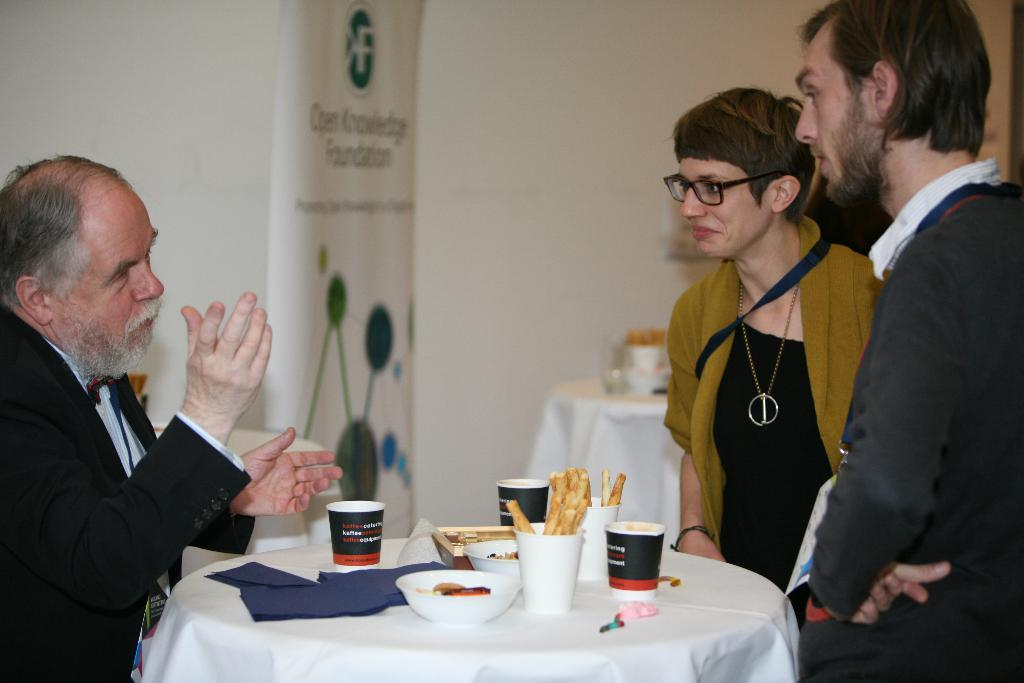How many people are present in the image? There are three people in the image. What is the position of one of the men in the image? One man is sitting. What is the man doing while sitting? The man is explaining something to another man and a woman. What can be seen on the table in the image? There are cups and eatables on the table. How many mice are present in the image? There are no mice present in the image. Can you tell me how many men are standing in the image? The provided facts do not mention any men standing in the image, only one man sitting. 